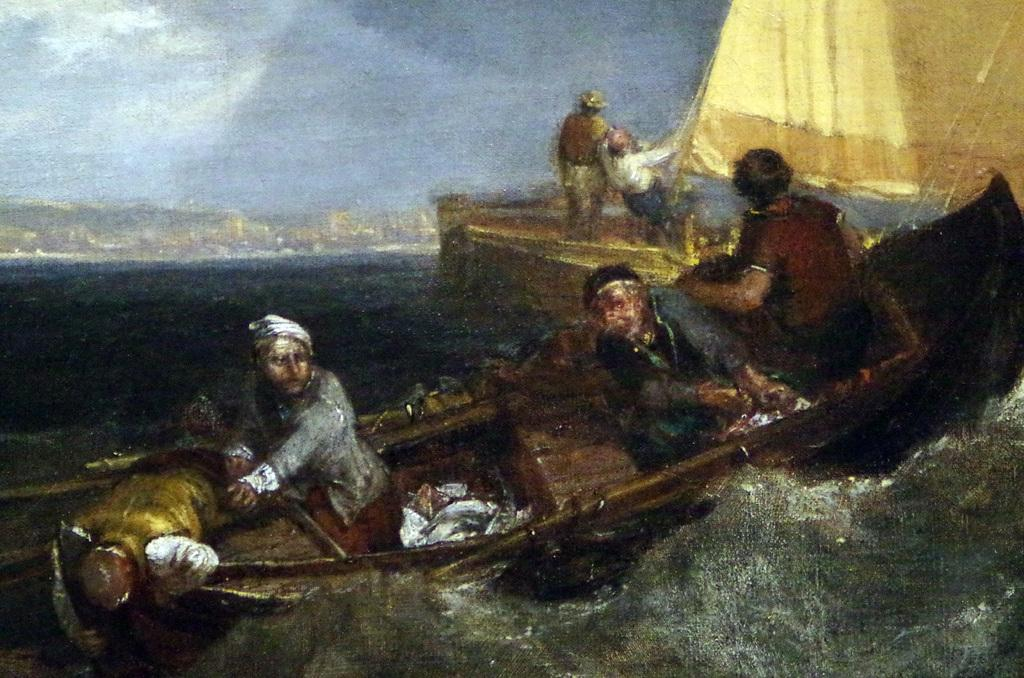What is the main subject of the painting in the image? The painting depicts people sailing on a boat. Where is the boat located in the painting? The boat is in the water. What type of slope can be seen in the painting? There is no slope present in the painting; it depicts people sailing on a boat in the water. What pen is used to create the painting? The facts provided do not mention the medium or tools used to create the painting, so it cannot be determined from the image. 